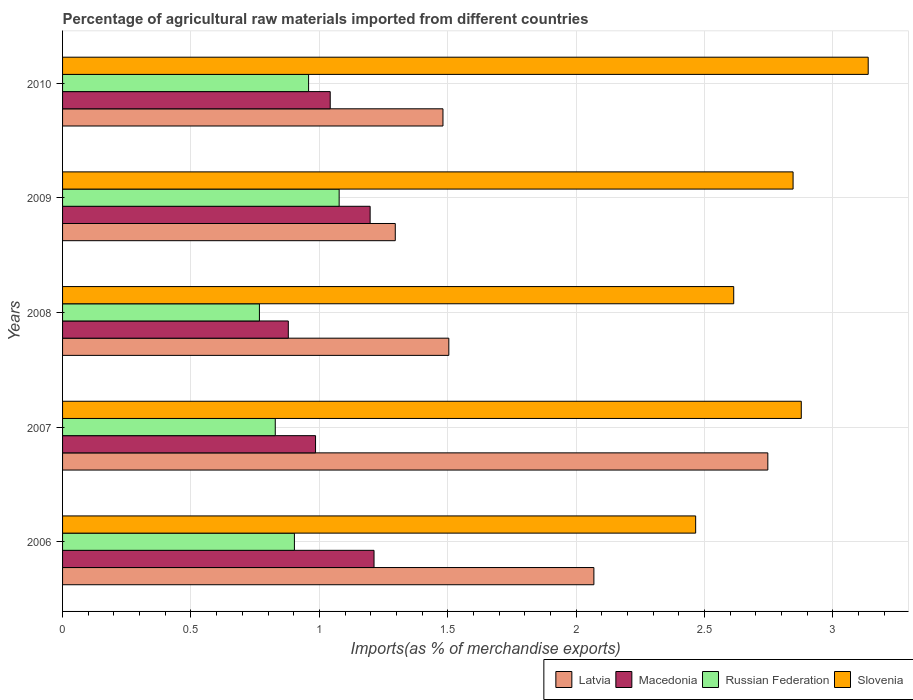How many different coloured bars are there?
Provide a short and direct response. 4. How many groups of bars are there?
Provide a short and direct response. 5. Are the number of bars per tick equal to the number of legend labels?
Your response must be concise. Yes. How many bars are there on the 5th tick from the bottom?
Your answer should be very brief. 4. What is the percentage of imports to different countries in Latvia in 2007?
Give a very brief answer. 2.75. Across all years, what is the maximum percentage of imports to different countries in Russian Federation?
Make the answer very short. 1.08. Across all years, what is the minimum percentage of imports to different countries in Russian Federation?
Make the answer very short. 0.77. In which year was the percentage of imports to different countries in Macedonia maximum?
Offer a very short reply. 2006. In which year was the percentage of imports to different countries in Latvia minimum?
Give a very brief answer. 2009. What is the total percentage of imports to different countries in Latvia in the graph?
Give a very brief answer. 9.1. What is the difference between the percentage of imports to different countries in Slovenia in 2008 and that in 2009?
Your response must be concise. -0.23. What is the difference between the percentage of imports to different countries in Macedonia in 2006 and the percentage of imports to different countries in Slovenia in 2007?
Give a very brief answer. -1.66. What is the average percentage of imports to different countries in Slovenia per year?
Your answer should be compact. 2.79. In the year 2007, what is the difference between the percentage of imports to different countries in Slovenia and percentage of imports to different countries in Latvia?
Keep it short and to the point. 0.13. In how many years, is the percentage of imports to different countries in Latvia greater than 2.4 %?
Give a very brief answer. 1. What is the ratio of the percentage of imports to different countries in Macedonia in 2006 to that in 2008?
Provide a short and direct response. 1.38. What is the difference between the highest and the second highest percentage of imports to different countries in Russian Federation?
Keep it short and to the point. 0.12. What is the difference between the highest and the lowest percentage of imports to different countries in Macedonia?
Provide a short and direct response. 0.33. What does the 2nd bar from the top in 2009 represents?
Give a very brief answer. Russian Federation. What does the 3rd bar from the bottom in 2008 represents?
Offer a very short reply. Russian Federation. Is it the case that in every year, the sum of the percentage of imports to different countries in Latvia and percentage of imports to different countries in Slovenia is greater than the percentage of imports to different countries in Russian Federation?
Provide a short and direct response. Yes. Are all the bars in the graph horizontal?
Ensure brevity in your answer.  Yes. Does the graph contain any zero values?
Keep it short and to the point. No. Does the graph contain grids?
Your response must be concise. Yes. Where does the legend appear in the graph?
Your answer should be compact. Bottom right. How are the legend labels stacked?
Offer a terse response. Horizontal. What is the title of the graph?
Your answer should be compact. Percentage of agricultural raw materials imported from different countries. Does "Oman" appear as one of the legend labels in the graph?
Provide a short and direct response. No. What is the label or title of the X-axis?
Provide a succinct answer. Imports(as % of merchandise exports). What is the Imports(as % of merchandise exports) of Latvia in 2006?
Your response must be concise. 2.07. What is the Imports(as % of merchandise exports) of Macedonia in 2006?
Keep it short and to the point. 1.21. What is the Imports(as % of merchandise exports) of Russian Federation in 2006?
Your answer should be very brief. 0.9. What is the Imports(as % of merchandise exports) of Slovenia in 2006?
Your answer should be compact. 2.47. What is the Imports(as % of merchandise exports) in Latvia in 2007?
Your answer should be very brief. 2.75. What is the Imports(as % of merchandise exports) in Macedonia in 2007?
Your answer should be compact. 0.99. What is the Imports(as % of merchandise exports) in Russian Federation in 2007?
Your response must be concise. 0.83. What is the Imports(as % of merchandise exports) in Slovenia in 2007?
Your answer should be compact. 2.88. What is the Imports(as % of merchandise exports) of Latvia in 2008?
Provide a succinct answer. 1.5. What is the Imports(as % of merchandise exports) in Macedonia in 2008?
Your answer should be compact. 0.88. What is the Imports(as % of merchandise exports) of Russian Federation in 2008?
Provide a short and direct response. 0.77. What is the Imports(as % of merchandise exports) in Slovenia in 2008?
Provide a succinct answer. 2.61. What is the Imports(as % of merchandise exports) in Latvia in 2009?
Give a very brief answer. 1.3. What is the Imports(as % of merchandise exports) in Macedonia in 2009?
Your response must be concise. 1.2. What is the Imports(as % of merchandise exports) in Russian Federation in 2009?
Keep it short and to the point. 1.08. What is the Imports(as % of merchandise exports) of Slovenia in 2009?
Your response must be concise. 2.84. What is the Imports(as % of merchandise exports) of Latvia in 2010?
Offer a terse response. 1.48. What is the Imports(as % of merchandise exports) in Macedonia in 2010?
Keep it short and to the point. 1.04. What is the Imports(as % of merchandise exports) in Russian Federation in 2010?
Provide a short and direct response. 0.96. What is the Imports(as % of merchandise exports) in Slovenia in 2010?
Your answer should be very brief. 3.14. Across all years, what is the maximum Imports(as % of merchandise exports) of Latvia?
Your answer should be compact. 2.75. Across all years, what is the maximum Imports(as % of merchandise exports) in Macedonia?
Provide a short and direct response. 1.21. Across all years, what is the maximum Imports(as % of merchandise exports) of Russian Federation?
Make the answer very short. 1.08. Across all years, what is the maximum Imports(as % of merchandise exports) of Slovenia?
Keep it short and to the point. 3.14. Across all years, what is the minimum Imports(as % of merchandise exports) in Latvia?
Give a very brief answer. 1.3. Across all years, what is the minimum Imports(as % of merchandise exports) in Macedonia?
Your answer should be very brief. 0.88. Across all years, what is the minimum Imports(as % of merchandise exports) of Russian Federation?
Your answer should be very brief. 0.77. Across all years, what is the minimum Imports(as % of merchandise exports) of Slovenia?
Provide a short and direct response. 2.47. What is the total Imports(as % of merchandise exports) in Latvia in the graph?
Your answer should be compact. 9.1. What is the total Imports(as % of merchandise exports) of Macedonia in the graph?
Give a very brief answer. 5.32. What is the total Imports(as % of merchandise exports) in Russian Federation in the graph?
Ensure brevity in your answer.  4.53. What is the total Imports(as % of merchandise exports) in Slovenia in the graph?
Give a very brief answer. 13.94. What is the difference between the Imports(as % of merchandise exports) of Latvia in 2006 and that in 2007?
Your response must be concise. -0.68. What is the difference between the Imports(as % of merchandise exports) of Macedonia in 2006 and that in 2007?
Ensure brevity in your answer.  0.23. What is the difference between the Imports(as % of merchandise exports) of Russian Federation in 2006 and that in 2007?
Ensure brevity in your answer.  0.07. What is the difference between the Imports(as % of merchandise exports) of Slovenia in 2006 and that in 2007?
Keep it short and to the point. -0.41. What is the difference between the Imports(as % of merchandise exports) in Latvia in 2006 and that in 2008?
Your answer should be very brief. 0.56. What is the difference between the Imports(as % of merchandise exports) of Macedonia in 2006 and that in 2008?
Give a very brief answer. 0.33. What is the difference between the Imports(as % of merchandise exports) of Russian Federation in 2006 and that in 2008?
Ensure brevity in your answer.  0.14. What is the difference between the Imports(as % of merchandise exports) of Slovenia in 2006 and that in 2008?
Make the answer very short. -0.15. What is the difference between the Imports(as % of merchandise exports) of Latvia in 2006 and that in 2009?
Your answer should be compact. 0.77. What is the difference between the Imports(as % of merchandise exports) of Macedonia in 2006 and that in 2009?
Your answer should be very brief. 0.02. What is the difference between the Imports(as % of merchandise exports) in Russian Federation in 2006 and that in 2009?
Your answer should be compact. -0.17. What is the difference between the Imports(as % of merchandise exports) of Slovenia in 2006 and that in 2009?
Make the answer very short. -0.38. What is the difference between the Imports(as % of merchandise exports) of Latvia in 2006 and that in 2010?
Ensure brevity in your answer.  0.59. What is the difference between the Imports(as % of merchandise exports) of Macedonia in 2006 and that in 2010?
Your response must be concise. 0.17. What is the difference between the Imports(as % of merchandise exports) in Russian Federation in 2006 and that in 2010?
Your answer should be very brief. -0.06. What is the difference between the Imports(as % of merchandise exports) in Slovenia in 2006 and that in 2010?
Your answer should be very brief. -0.67. What is the difference between the Imports(as % of merchandise exports) in Latvia in 2007 and that in 2008?
Provide a succinct answer. 1.24. What is the difference between the Imports(as % of merchandise exports) in Macedonia in 2007 and that in 2008?
Your answer should be very brief. 0.11. What is the difference between the Imports(as % of merchandise exports) of Russian Federation in 2007 and that in 2008?
Your response must be concise. 0.06. What is the difference between the Imports(as % of merchandise exports) in Slovenia in 2007 and that in 2008?
Make the answer very short. 0.26. What is the difference between the Imports(as % of merchandise exports) in Latvia in 2007 and that in 2009?
Provide a succinct answer. 1.45. What is the difference between the Imports(as % of merchandise exports) in Macedonia in 2007 and that in 2009?
Ensure brevity in your answer.  -0.21. What is the difference between the Imports(as % of merchandise exports) in Russian Federation in 2007 and that in 2009?
Make the answer very short. -0.25. What is the difference between the Imports(as % of merchandise exports) in Slovenia in 2007 and that in 2009?
Provide a short and direct response. 0.03. What is the difference between the Imports(as % of merchandise exports) of Latvia in 2007 and that in 2010?
Ensure brevity in your answer.  1.26. What is the difference between the Imports(as % of merchandise exports) in Macedonia in 2007 and that in 2010?
Your answer should be compact. -0.06. What is the difference between the Imports(as % of merchandise exports) in Russian Federation in 2007 and that in 2010?
Keep it short and to the point. -0.13. What is the difference between the Imports(as % of merchandise exports) in Slovenia in 2007 and that in 2010?
Your answer should be very brief. -0.26. What is the difference between the Imports(as % of merchandise exports) in Latvia in 2008 and that in 2009?
Ensure brevity in your answer.  0.21. What is the difference between the Imports(as % of merchandise exports) of Macedonia in 2008 and that in 2009?
Give a very brief answer. -0.32. What is the difference between the Imports(as % of merchandise exports) in Russian Federation in 2008 and that in 2009?
Make the answer very short. -0.31. What is the difference between the Imports(as % of merchandise exports) in Slovenia in 2008 and that in 2009?
Your answer should be very brief. -0.23. What is the difference between the Imports(as % of merchandise exports) in Latvia in 2008 and that in 2010?
Your answer should be compact. 0.02. What is the difference between the Imports(as % of merchandise exports) of Macedonia in 2008 and that in 2010?
Ensure brevity in your answer.  -0.16. What is the difference between the Imports(as % of merchandise exports) in Russian Federation in 2008 and that in 2010?
Provide a succinct answer. -0.19. What is the difference between the Imports(as % of merchandise exports) of Slovenia in 2008 and that in 2010?
Give a very brief answer. -0.52. What is the difference between the Imports(as % of merchandise exports) of Latvia in 2009 and that in 2010?
Provide a succinct answer. -0.19. What is the difference between the Imports(as % of merchandise exports) in Macedonia in 2009 and that in 2010?
Ensure brevity in your answer.  0.16. What is the difference between the Imports(as % of merchandise exports) in Russian Federation in 2009 and that in 2010?
Offer a very short reply. 0.12. What is the difference between the Imports(as % of merchandise exports) in Slovenia in 2009 and that in 2010?
Provide a succinct answer. -0.29. What is the difference between the Imports(as % of merchandise exports) in Latvia in 2006 and the Imports(as % of merchandise exports) in Macedonia in 2007?
Give a very brief answer. 1.08. What is the difference between the Imports(as % of merchandise exports) in Latvia in 2006 and the Imports(as % of merchandise exports) in Russian Federation in 2007?
Ensure brevity in your answer.  1.24. What is the difference between the Imports(as % of merchandise exports) of Latvia in 2006 and the Imports(as % of merchandise exports) of Slovenia in 2007?
Offer a terse response. -0.81. What is the difference between the Imports(as % of merchandise exports) of Macedonia in 2006 and the Imports(as % of merchandise exports) of Russian Federation in 2007?
Ensure brevity in your answer.  0.38. What is the difference between the Imports(as % of merchandise exports) in Macedonia in 2006 and the Imports(as % of merchandise exports) in Slovenia in 2007?
Give a very brief answer. -1.66. What is the difference between the Imports(as % of merchandise exports) in Russian Federation in 2006 and the Imports(as % of merchandise exports) in Slovenia in 2007?
Offer a very short reply. -1.97. What is the difference between the Imports(as % of merchandise exports) in Latvia in 2006 and the Imports(as % of merchandise exports) in Macedonia in 2008?
Your answer should be very brief. 1.19. What is the difference between the Imports(as % of merchandise exports) in Latvia in 2006 and the Imports(as % of merchandise exports) in Russian Federation in 2008?
Give a very brief answer. 1.3. What is the difference between the Imports(as % of merchandise exports) of Latvia in 2006 and the Imports(as % of merchandise exports) of Slovenia in 2008?
Provide a succinct answer. -0.54. What is the difference between the Imports(as % of merchandise exports) in Macedonia in 2006 and the Imports(as % of merchandise exports) in Russian Federation in 2008?
Give a very brief answer. 0.45. What is the difference between the Imports(as % of merchandise exports) in Macedonia in 2006 and the Imports(as % of merchandise exports) in Slovenia in 2008?
Your answer should be compact. -1.4. What is the difference between the Imports(as % of merchandise exports) of Russian Federation in 2006 and the Imports(as % of merchandise exports) of Slovenia in 2008?
Keep it short and to the point. -1.71. What is the difference between the Imports(as % of merchandise exports) of Latvia in 2006 and the Imports(as % of merchandise exports) of Macedonia in 2009?
Give a very brief answer. 0.87. What is the difference between the Imports(as % of merchandise exports) of Latvia in 2006 and the Imports(as % of merchandise exports) of Russian Federation in 2009?
Your response must be concise. 0.99. What is the difference between the Imports(as % of merchandise exports) in Latvia in 2006 and the Imports(as % of merchandise exports) in Slovenia in 2009?
Make the answer very short. -0.78. What is the difference between the Imports(as % of merchandise exports) in Macedonia in 2006 and the Imports(as % of merchandise exports) in Russian Federation in 2009?
Provide a succinct answer. 0.14. What is the difference between the Imports(as % of merchandise exports) of Macedonia in 2006 and the Imports(as % of merchandise exports) of Slovenia in 2009?
Keep it short and to the point. -1.63. What is the difference between the Imports(as % of merchandise exports) in Russian Federation in 2006 and the Imports(as % of merchandise exports) in Slovenia in 2009?
Make the answer very short. -1.94. What is the difference between the Imports(as % of merchandise exports) of Latvia in 2006 and the Imports(as % of merchandise exports) of Macedonia in 2010?
Your response must be concise. 1.03. What is the difference between the Imports(as % of merchandise exports) in Latvia in 2006 and the Imports(as % of merchandise exports) in Russian Federation in 2010?
Make the answer very short. 1.11. What is the difference between the Imports(as % of merchandise exports) of Latvia in 2006 and the Imports(as % of merchandise exports) of Slovenia in 2010?
Offer a terse response. -1.07. What is the difference between the Imports(as % of merchandise exports) in Macedonia in 2006 and the Imports(as % of merchandise exports) in Russian Federation in 2010?
Ensure brevity in your answer.  0.25. What is the difference between the Imports(as % of merchandise exports) in Macedonia in 2006 and the Imports(as % of merchandise exports) in Slovenia in 2010?
Provide a succinct answer. -1.92. What is the difference between the Imports(as % of merchandise exports) in Russian Federation in 2006 and the Imports(as % of merchandise exports) in Slovenia in 2010?
Offer a very short reply. -2.23. What is the difference between the Imports(as % of merchandise exports) in Latvia in 2007 and the Imports(as % of merchandise exports) in Macedonia in 2008?
Ensure brevity in your answer.  1.87. What is the difference between the Imports(as % of merchandise exports) of Latvia in 2007 and the Imports(as % of merchandise exports) of Russian Federation in 2008?
Provide a short and direct response. 1.98. What is the difference between the Imports(as % of merchandise exports) of Latvia in 2007 and the Imports(as % of merchandise exports) of Slovenia in 2008?
Your answer should be compact. 0.13. What is the difference between the Imports(as % of merchandise exports) in Macedonia in 2007 and the Imports(as % of merchandise exports) in Russian Federation in 2008?
Provide a short and direct response. 0.22. What is the difference between the Imports(as % of merchandise exports) in Macedonia in 2007 and the Imports(as % of merchandise exports) in Slovenia in 2008?
Keep it short and to the point. -1.63. What is the difference between the Imports(as % of merchandise exports) of Russian Federation in 2007 and the Imports(as % of merchandise exports) of Slovenia in 2008?
Keep it short and to the point. -1.79. What is the difference between the Imports(as % of merchandise exports) of Latvia in 2007 and the Imports(as % of merchandise exports) of Macedonia in 2009?
Your answer should be compact. 1.55. What is the difference between the Imports(as % of merchandise exports) in Latvia in 2007 and the Imports(as % of merchandise exports) in Russian Federation in 2009?
Offer a terse response. 1.67. What is the difference between the Imports(as % of merchandise exports) of Latvia in 2007 and the Imports(as % of merchandise exports) of Slovenia in 2009?
Keep it short and to the point. -0.1. What is the difference between the Imports(as % of merchandise exports) in Macedonia in 2007 and the Imports(as % of merchandise exports) in Russian Federation in 2009?
Give a very brief answer. -0.09. What is the difference between the Imports(as % of merchandise exports) in Macedonia in 2007 and the Imports(as % of merchandise exports) in Slovenia in 2009?
Make the answer very short. -1.86. What is the difference between the Imports(as % of merchandise exports) of Russian Federation in 2007 and the Imports(as % of merchandise exports) of Slovenia in 2009?
Your response must be concise. -2.02. What is the difference between the Imports(as % of merchandise exports) in Latvia in 2007 and the Imports(as % of merchandise exports) in Macedonia in 2010?
Your answer should be very brief. 1.7. What is the difference between the Imports(as % of merchandise exports) of Latvia in 2007 and the Imports(as % of merchandise exports) of Russian Federation in 2010?
Give a very brief answer. 1.79. What is the difference between the Imports(as % of merchandise exports) of Latvia in 2007 and the Imports(as % of merchandise exports) of Slovenia in 2010?
Offer a very short reply. -0.39. What is the difference between the Imports(as % of merchandise exports) in Macedonia in 2007 and the Imports(as % of merchandise exports) in Russian Federation in 2010?
Your response must be concise. 0.03. What is the difference between the Imports(as % of merchandise exports) of Macedonia in 2007 and the Imports(as % of merchandise exports) of Slovenia in 2010?
Your answer should be compact. -2.15. What is the difference between the Imports(as % of merchandise exports) of Russian Federation in 2007 and the Imports(as % of merchandise exports) of Slovenia in 2010?
Provide a succinct answer. -2.31. What is the difference between the Imports(as % of merchandise exports) of Latvia in 2008 and the Imports(as % of merchandise exports) of Macedonia in 2009?
Provide a short and direct response. 0.31. What is the difference between the Imports(as % of merchandise exports) in Latvia in 2008 and the Imports(as % of merchandise exports) in Russian Federation in 2009?
Your response must be concise. 0.43. What is the difference between the Imports(as % of merchandise exports) in Latvia in 2008 and the Imports(as % of merchandise exports) in Slovenia in 2009?
Give a very brief answer. -1.34. What is the difference between the Imports(as % of merchandise exports) of Macedonia in 2008 and the Imports(as % of merchandise exports) of Russian Federation in 2009?
Offer a terse response. -0.2. What is the difference between the Imports(as % of merchandise exports) in Macedonia in 2008 and the Imports(as % of merchandise exports) in Slovenia in 2009?
Your answer should be very brief. -1.97. What is the difference between the Imports(as % of merchandise exports) in Russian Federation in 2008 and the Imports(as % of merchandise exports) in Slovenia in 2009?
Keep it short and to the point. -2.08. What is the difference between the Imports(as % of merchandise exports) of Latvia in 2008 and the Imports(as % of merchandise exports) of Macedonia in 2010?
Your answer should be very brief. 0.46. What is the difference between the Imports(as % of merchandise exports) in Latvia in 2008 and the Imports(as % of merchandise exports) in Russian Federation in 2010?
Provide a short and direct response. 0.55. What is the difference between the Imports(as % of merchandise exports) of Latvia in 2008 and the Imports(as % of merchandise exports) of Slovenia in 2010?
Give a very brief answer. -1.63. What is the difference between the Imports(as % of merchandise exports) in Macedonia in 2008 and the Imports(as % of merchandise exports) in Russian Federation in 2010?
Keep it short and to the point. -0.08. What is the difference between the Imports(as % of merchandise exports) in Macedonia in 2008 and the Imports(as % of merchandise exports) in Slovenia in 2010?
Offer a very short reply. -2.26. What is the difference between the Imports(as % of merchandise exports) of Russian Federation in 2008 and the Imports(as % of merchandise exports) of Slovenia in 2010?
Provide a short and direct response. -2.37. What is the difference between the Imports(as % of merchandise exports) in Latvia in 2009 and the Imports(as % of merchandise exports) in Macedonia in 2010?
Offer a terse response. 0.25. What is the difference between the Imports(as % of merchandise exports) of Latvia in 2009 and the Imports(as % of merchandise exports) of Russian Federation in 2010?
Your response must be concise. 0.34. What is the difference between the Imports(as % of merchandise exports) in Latvia in 2009 and the Imports(as % of merchandise exports) in Slovenia in 2010?
Your response must be concise. -1.84. What is the difference between the Imports(as % of merchandise exports) of Macedonia in 2009 and the Imports(as % of merchandise exports) of Russian Federation in 2010?
Provide a succinct answer. 0.24. What is the difference between the Imports(as % of merchandise exports) of Macedonia in 2009 and the Imports(as % of merchandise exports) of Slovenia in 2010?
Offer a terse response. -1.94. What is the difference between the Imports(as % of merchandise exports) in Russian Federation in 2009 and the Imports(as % of merchandise exports) in Slovenia in 2010?
Your answer should be very brief. -2.06. What is the average Imports(as % of merchandise exports) in Latvia per year?
Your answer should be compact. 1.82. What is the average Imports(as % of merchandise exports) in Macedonia per year?
Your response must be concise. 1.06. What is the average Imports(as % of merchandise exports) in Russian Federation per year?
Make the answer very short. 0.91. What is the average Imports(as % of merchandise exports) in Slovenia per year?
Your response must be concise. 2.79. In the year 2006, what is the difference between the Imports(as % of merchandise exports) in Latvia and Imports(as % of merchandise exports) in Macedonia?
Keep it short and to the point. 0.86. In the year 2006, what is the difference between the Imports(as % of merchandise exports) in Latvia and Imports(as % of merchandise exports) in Russian Federation?
Offer a very short reply. 1.17. In the year 2006, what is the difference between the Imports(as % of merchandise exports) in Latvia and Imports(as % of merchandise exports) in Slovenia?
Offer a terse response. -0.4. In the year 2006, what is the difference between the Imports(as % of merchandise exports) in Macedonia and Imports(as % of merchandise exports) in Russian Federation?
Your response must be concise. 0.31. In the year 2006, what is the difference between the Imports(as % of merchandise exports) in Macedonia and Imports(as % of merchandise exports) in Slovenia?
Give a very brief answer. -1.25. In the year 2006, what is the difference between the Imports(as % of merchandise exports) in Russian Federation and Imports(as % of merchandise exports) in Slovenia?
Your answer should be compact. -1.56. In the year 2007, what is the difference between the Imports(as % of merchandise exports) of Latvia and Imports(as % of merchandise exports) of Macedonia?
Offer a very short reply. 1.76. In the year 2007, what is the difference between the Imports(as % of merchandise exports) of Latvia and Imports(as % of merchandise exports) of Russian Federation?
Ensure brevity in your answer.  1.92. In the year 2007, what is the difference between the Imports(as % of merchandise exports) of Latvia and Imports(as % of merchandise exports) of Slovenia?
Your response must be concise. -0.13. In the year 2007, what is the difference between the Imports(as % of merchandise exports) in Macedonia and Imports(as % of merchandise exports) in Russian Federation?
Make the answer very short. 0.16. In the year 2007, what is the difference between the Imports(as % of merchandise exports) of Macedonia and Imports(as % of merchandise exports) of Slovenia?
Make the answer very short. -1.89. In the year 2007, what is the difference between the Imports(as % of merchandise exports) in Russian Federation and Imports(as % of merchandise exports) in Slovenia?
Offer a very short reply. -2.05. In the year 2008, what is the difference between the Imports(as % of merchandise exports) of Latvia and Imports(as % of merchandise exports) of Macedonia?
Your answer should be compact. 0.63. In the year 2008, what is the difference between the Imports(as % of merchandise exports) of Latvia and Imports(as % of merchandise exports) of Russian Federation?
Your answer should be compact. 0.74. In the year 2008, what is the difference between the Imports(as % of merchandise exports) of Latvia and Imports(as % of merchandise exports) of Slovenia?
Make the answer very short. -1.11. In the year 2008, what is the difference between the Imports(as % of merchandise exports) in Macedonia and Imports(as % of merchandise exports) in Russian Federation?
Your answer should be compact. 0.11. In the year 2008, what is the difference between the Imports(as % of merchandise exports) of Macedonia and Imports(as % of merchandise exports) of Slovenia?
Your answer should be very brief. -1.73. In the year 2008, what is the difference between the Imports(as % of merchandise exports) of Russian Federation and Imports(as % of merchandise exports) of Slovenia?
Offer a very short reply. -1.85. In the year 2009, what is the difference between the Imports(as % of merchandise exports) of Latvia and Imports(as % of merchandise exports) of Macedonia?
Provide a succinct answer. 0.1. In the year 2009, what is the difference between the Imports(as % of merchandise exports) in Latvia and Imports(as % of merchandise exports) in Russian Federation?
Your answer should be compact. 0.22. In the year 2009, what is the difference between the Imports(as % of merchandise exports) of Latvia and Imports(as % of merchandise exports) of Slovenia?
Keep it short and to the point. -1.55. In the year 2009, what is the difference between the Imports(as % of merchandise exports) of Macedonia and Imports(as % of merchandise exports) of Russian Federation?
Your answer should be very brief. 0.12. In the year 2009, what is the difference between the Imports(as % of merchandise exports) in Macedonia and Imports(as % of merchandise exports) in Slovenia?
Your answer should be compact. -1.65. In the year 2009, what is the difference between the Imports(as % of merchandise exports) of Russian Federation and Imports(as % of merchandise exports) of Slovenia?
Your answer should be compact. -1.77. In the year 2010, what is the difference between the Imports(as % of merchandise exports) of Latvia and Imports(as % of merchandise exports) of Macedonia?
Offer a terse response. 0.44. In the year 2010, what is the difference between the Imports(as % of merchandise exports) in Latvia and Imports(as % of merchandise exports) in Russian Federation?
Provide a succinct answer. 0.52. In the year 2010, what is the difference between the Imports(as % of merchandise exports) in Latvia and Imports(as % of merchandise exports) in Slovenia?
Your response must be concise. -1.66. In the year 2010, what is the difference between the Imports(as % of merchandise exports) in Macedonia and Imports(as % of merchandise exports) in Russian Federation?
Your answer should be very brief. 0.08. In the year 2010, what is the difference between the Imports(as % of merchandise exports) in Macedonia and Imports(as % of merchandise exports) in Slovenia?
Offer a terse response. -2.1. In the year 2010, what is the difference between the Imports(as % of merchandise exports) of Russian Federation and Imports(as % of merchandise exports) of Slovenia?
Keep it short and to the point. -2.18. What is the ratio of the Imports(as % of merchandise exports) of Latvia in 2006 to that in 2007?
Provide a short and direct response. 0.75. What is the ratio of the Imports(as % of merchandise exports) of Macedonia in 2006 to that in 2007?
Offer a terse response. 1.23. What is the ratio of the Imports(as % of merchandise exports) in Russian Federation in 2006 to that in 2007?
Your response must be concise. 1.09. What is the ratio of the Imports(as % of merchandise exports) in Slovenia in 2006 to that in 2007?
Offer a very short reply. 0.86. What is the ratio of the Imports(as % of merchandise exports) of Latvia in 2006 to that in 2008?
Keep it short and to the point. 1.38. What is the ratio of the Imports(as % of merchandise exports) of Macedonia in 2006 to that in 2008?
Your answer should be very brief. 1.38. What is the ratio of the Imports(as % of merchandise exports) of Russian Federation in 2006 to that in 2008?
Your response must be concise. 1.18. What is the ratio of the Imports(as % of merchandise exports) in Slovenia in 2006 to that in 2008?
Provide a short and direct response. 0.94. What is the ratio of the Imports(as % of merchandise exports) in Latvia in 2006 to that in 2009?
Ensure brevity in your answer.  1.6. What is the ratio of the Imports(as % of merchandise exports) in Macedonia in 2006 to that in 2009?
Your answer should be compact. 1.01. What is the ratio of the Imports(as % of merchandise exports) in Russian Federation in 2006 to that in 2009?
Provide a succinct answer. 0.84. What is the ratio of the Imports(as % of merchandise exports) in Slovenia in 2006 to that in 2009?
Your response must be concise. 0.87. What is the ratio of the Imports(as % of merchandise exports) in Latvia in 2006 to that in 2010?
Ensure brevity in your answer.  1.4. What is the ratio of the Imports(as % of merchandise exports) in Macedonia in 2006 to that in 2010?
Make the answer very short. 1.16. What is the ratio of the Imports(as % of merchandise exports) of Russian Federation in 2006 to that in 2010?
Provide a short and direct response. 0.94. What is the ratio of the Imports(as % of merchandise exports) in Slovenia in 2006 to that in 2010?
Ensure brevity in your answer.  0.79. What is the ratio of the Imports(as % of merchandise exports) in Latvia in 2007 to that in 2008?
Offer a very short reply. 1.83. What is the ratio of the Imports(as % of merchandise exports) in Macedonia in 2007 to that in 2008?
Your response must be concise. 1.12. What is the ratio of the Imports(as % of merchandise exports) of Russian Federation in 2007 to that in 2008?
Your response must be concise. 1.08. What is the ratio of the Imports(as % of merchandise exports) of Slovenia in 2007 to that in 2008?
Provide a succinct answer. 1.1. What is the ratio of the Imports(as % of merchandise exports) of Latvia in 2007 to that in 2009?
Give a very brief answer. 2.12. What is the ratio of the Imports(as % of merchandise exports) in Macedonia in 2007 to that in 2009?
Provide a succinct answer. 0.82. What is the ratio of the Imports(as % of merchandise exports) in Russian Federation in 2007 to that in 2009?
Keep it short and to the point. 0.77. What is the ratio of the Imports(as % of merchandise exports) in Slovenia in 2007 to that in 2009?
Keep it short and to the point. 1.01. What is the ratio of the Imports(as % of merchandise exports) of Latvia in 2007 to that in 2010?
Make the answer very short. 1.85. What is the ratio of the Imports(as % of merchandise exports) in Macedonia in 2007 to that in 2010?
Offer a very short reply. 0.95. What is the ratio of the Imports(as % of merchandise exports) of Russian Federation in 2007 to that in 2010?
Your answer should be compact. 0.86. What is the ratio of the Imports(as % of merchandise exports) in Slovenia in 2007 to that in 2010?
Your response must be concise. 0.92. What is the ratio of the Imports(as % of merchandise exports) in Latvia in 2008 to that in 2009?
Offer a terse response. 1.16. What is the ratio of the Imports(as % of merchandise exports) of Macedonia in 2008 to that in 2009?
Your answer should be compact. 0.73. What is the ratio of the Imports(as % of merchandise exports) of Russian Federation in 2008 to that in 2009?
Give a very brief answer. 0.71. What is the ratio of the Imports(as % of merchandise exports) of Slovenia in 2008 to that in 2009?
Give a very brief answer. 0.92. What is the ratio of the Imports(as % of merchandise exports) in Latvia in 2008 to that in 2010?
Your response must be concise. 1.02. What is the ratio of the Imports(as % of merchandise exports) of Macedonia in 2008 to that in 2010?
Make the answer very short. 0.84. What is the ratio of the Imports(as % of merchandise exports) of Russian Federation in 2008 to that in 2010?
Offer a very short reply. 0.8. What is the ratio of the Imports(as % of merchandise exports) of Slovenia in 2008 to that in 2010?
Keep it short and to the point. 0.83. What is the ratio of the Imports(as % of merchandise exports) in Latvia in 2009 to that in 2010?
Your answer should be very brief. 0.87. What is the ratio of the Imports(as % of merchandise exports) of Macedonia in 2009 to that in 2010?
Provide a succinct answer. 1.15. What is the ratio of the Imports(as % of merchandise exports) of Russian Federation in 2009 to that in 2010?
Offer a terse response. 1.12. What is the ratio of the Imports(as % of merchandise exports) of Slovenia in 2009 to that in 2010?
Keep it short and to the point. 0.91. What is the difference between the highest and the second highest Imports(as % of merchandise exports) of Latvia?
Give a very brief answer. 0.68. What is the difference between the highest and the second highest Imports(as % of merchandise exports) in Macedonia?
Offer a terse response. 0.02. What is the difference between the highest and the second highest Imports(as % of merchandise exports) in Russian Federation?
Your answer should be compact. 0.12. What is the difference between the highest and the second highest Imports(as % of merchandise exports) of Slovenia?
Make the answer very short. 0.26. What is the difference between the highest and the lowest Imports(as % of merchandise exports) in Latvia?
Offer a very short reply. 1.45. What is the difference between the highest and the lowest Imports(as % of merchandise exports) of Macedonia?
Provide a short and direct response. 0.33. What is the difference between the highest and the lowest Imports(as % of merchandise exports) of Russian Federation?
Offer a very short reply. 0.31. What is the difference between the highest and the lowest Imports(as % of merchandise exports) in Slovenia?
Ensure brevity in your answer.  0.67. 